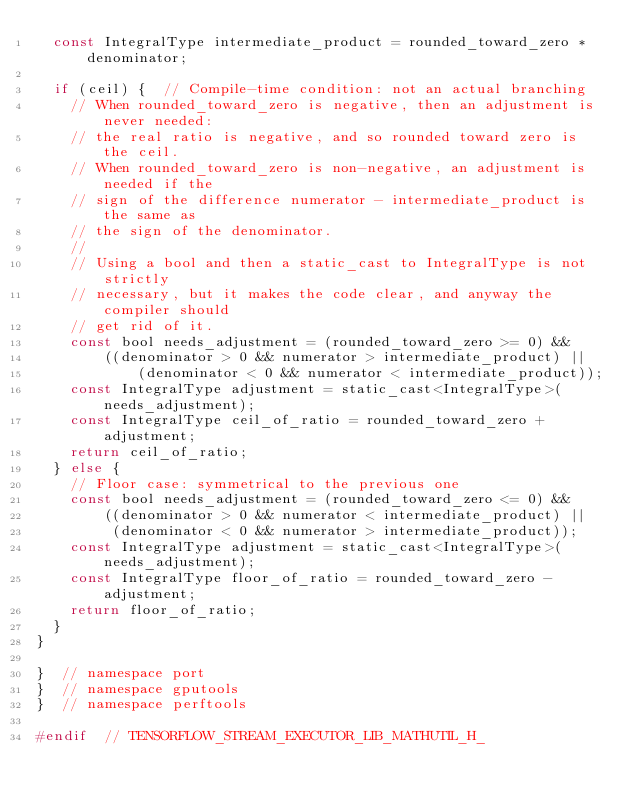Convert code to text. <code><loc_0><loc_0><loc_500><loc_500><_C_>  const IntegralType intermediate_product = rounded_toward_zero * denominator;

  if (ceil) {  // Compile-time condition: not an actual branching
    // When rounded_toward_zero is negative, then an adjustment is never needed:
    // the real ratio is negative, and so rounded toward zero is the ceil.
    // When rounded_toward_zero is non-negative, an adjustment is needed if the
    // sign of the difference numerator - intermediate_product is the same as
    // the sign of the denominator.
    //
    // Using a bool and then a static_cast to IntegralType is not strictly
    // necessary, but it makes the code clear, and anyway the compiler should
    // get rid of it.
    const bool needs_adjustment = (rounded_toward_zero >= 0) &&
        ((denominator > 0 && numerator > intermediate_product) ||
            (denominator < 0 && numerator < intermediate_product));
    const IntegralType adjustment = static_cast<IntegralType>(needs_adjustment);
    const IntegralType ceil_of_ratio = rounded_toward_zero + adjustment;
    return ceil_of_ratio;
  } else {
    // Floor case: symmetrical to the previous one
    const bool needs_adjustment = (rounded_toward_zero <= 0) &&
        ((denominator > 0 && numerator < intermediate_product) ||
         (denominator < 0 && numerator > intermediate_product));
    const IntegralType adjustment = static_cast<IntegralType>(needs_adjustment);
    const IntegralType floor_of_ratio = rounded_toward_zero - adjustment;
    return floor_of_ratio;
  }
}

}  // namespace port
}  // namespace gputools
}  // namespace perftools

#endif  // TENSORFLOW_STREAM_EXECUTOR_LIB_MATHUTIL_H_
</code> 